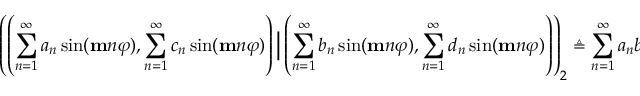<formula> <loc_0><loc_0><loc_500><loc_500>\left ( \left ( \sum _ { n = 1 } ^ { \infty } a _ { n } \sin ( m n \varphi ) , \sum _ { n = 1 } ^ { \infty } c _ { n } \sin ( m n \varphi ) \right ) \Big | \left ( \sum _ { n = 1 } ^ { \infty } b _ { n } \sin ( m n \varphi ) , \sum _ { n = 1 } ^ { \infty } d _ { n } \sin ( m n \varphi ) \right ) \right ) _ { 2 } \triangle q \sum _ { n = 1 } ^ { \infty } a _ { n } b _ { n } + c _ { n } d _ { n } .</formula> 